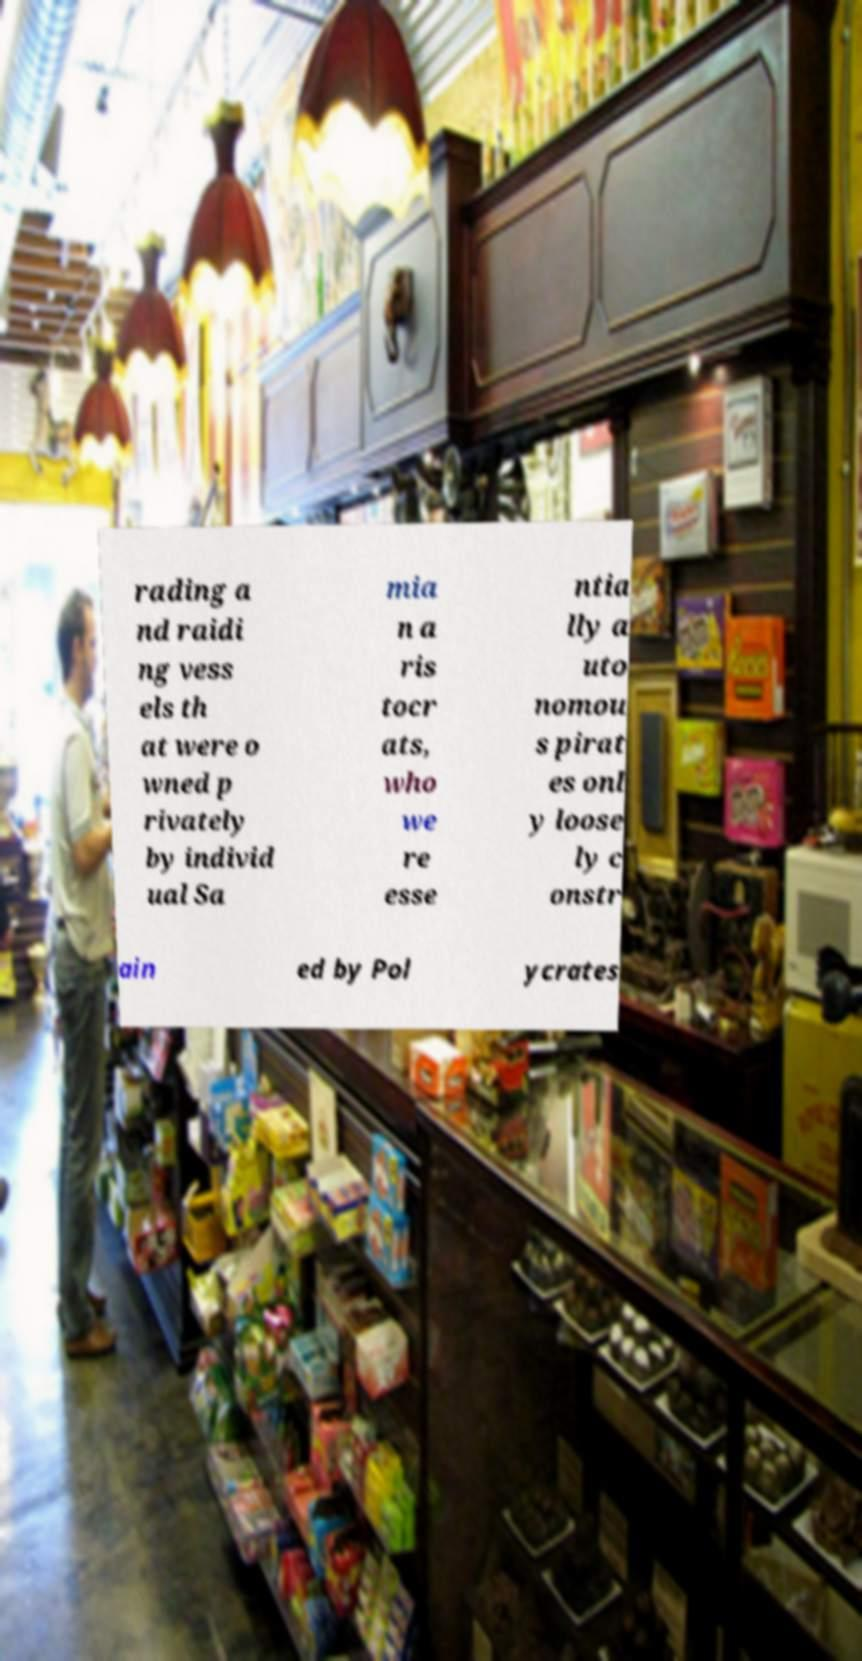For documentation purposes, I need the text within this image transcribed. Could you provide that? rading a nd raidi ng vess els th at were o wned p rivately by individ ual Sa mia n a ris tocr ats, who we re esse ntia lly a uto nomou s pirat es onl y loose ly c onstr ain ed by Pol ycrates 